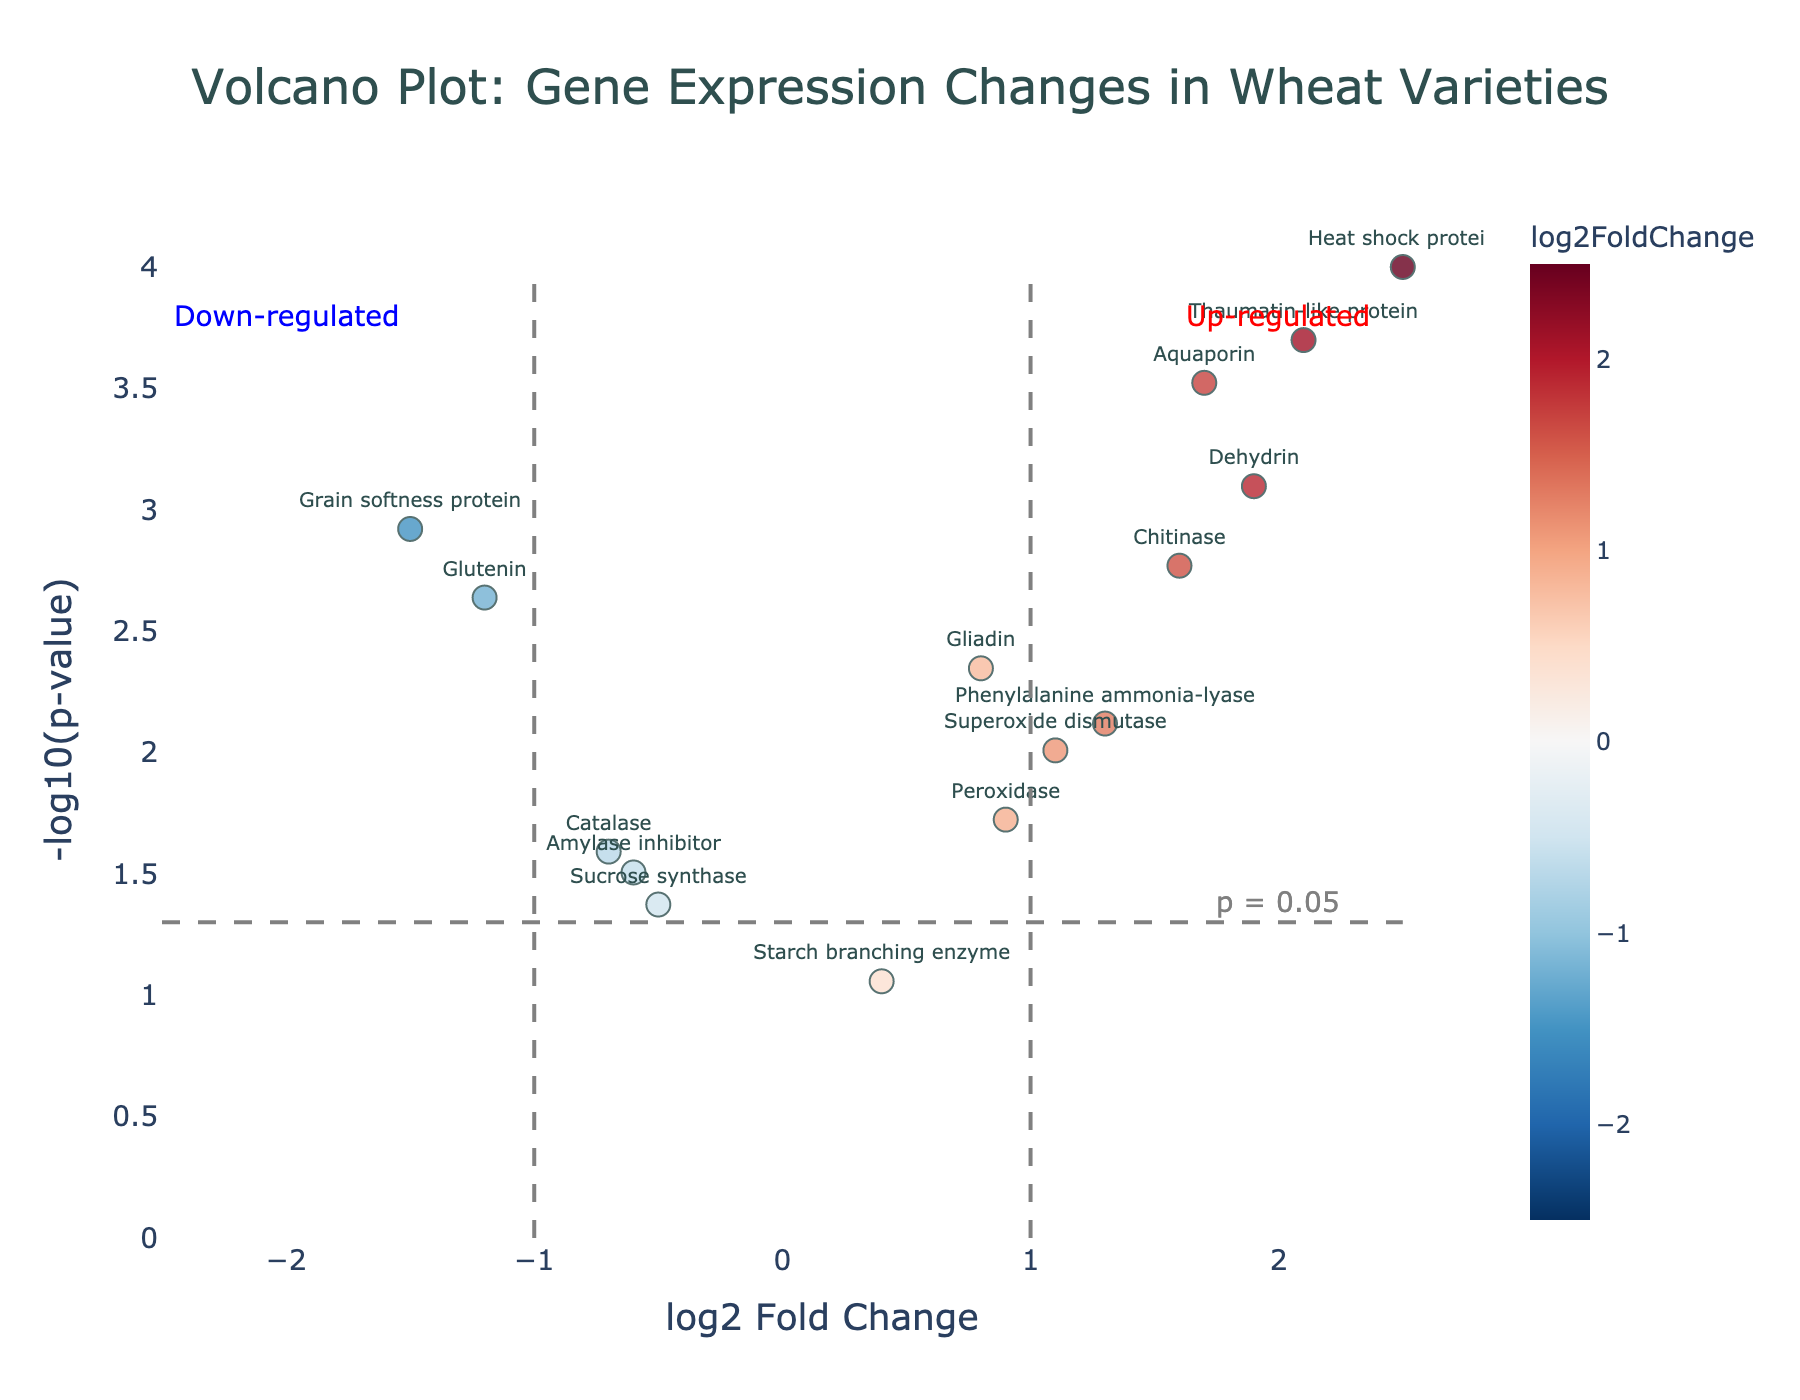What is the title of the figure? Look at the top of the figure where the title is displayed prominently in a larger font. The title clearly describes what the plot is about.
Answer: Volcano Plot: Gene Expression Changes in Wheat Varieties How many genes are analyzed in this plot? Count the number of data points (dots) on the plot, as each dot represents a gene. You should find 14 dots.
Answer: 14 Which gene has the highest log2 Fold Change? Identify the gene with the highest value on the x-axis (log2 Fold Change). The "Heat shock protein" gene is located at the highest x-axis value.
Answer: Heat shock protein Which gene has the lowest p-value? To find the gene with the lowest p-value, look for the highest point on the y-axis since p-values are transformed to -log10(p-value). The "Heat shock protein" gene is the highest on the y-axis.
Answer: Heat shock protein Are there more up-regulated or down-regulated genes? Look at the number of data points to the right of the zero line on the x-axis (up-regulated) and to the left (down-regulated). Count each and compare.
Answer: More up-regulated genes Which up-regulated gene has the least change in expression? Among the positive log2 Fold Change values (right side of the vertical zero line), identify the smallest log2 Fold Change value. "Starch branching enzyme" has the smallest positive change at 0.4.
Answer: Starch branching enzyme Identify the genes that are significantly down-regulated. Significant genes have a p-value less than 0.05 (-log10(p-value) > 1.301). Look at the left side of the plot (negative log2 Fold Change) and check for points above the horizontal line at y = 1.301. "Glutenin," "Amylase inhibitor," "Catalase," "Grain softness protein," and "Sucrose synthase" are the significantly down-regulated genes.
Answer: Glutenin, Amylase inhibitor, Catalase, Grain softness protein, Sucrose synthase What is the log2 Fold Change and p-value of 'Phenylalanine ammonia-lyase'? Identify the point labeled "Phenylalanine ammonia-lyase" and read off the x-axis (log2 Fold Change) and y-axis (-log10(p-value)) values. The log2 Fold Change is 1.3 and the p-value corresponding to the -log10(p-value) value gives approximately 0.0076.
Answer: Log2 Fold Change: 1.3, p-value: 0.0076 